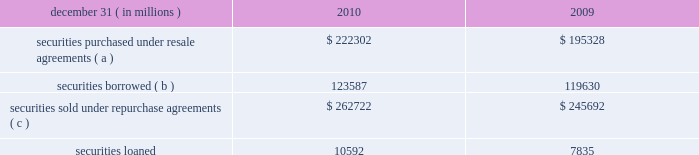Jpmorgan chase & co./2010 annual report 219 note 13 2013 securities financing activities jpmorgan chase enters into resale agreements , repurchase agreements , securities borrowed transactions and securities loaned transactions ( collectively , 201csecurities financing agree- ments 201d ) primarily to finance the firm 2019s inventory positions , ac- quire securities to cover short positions , accommodate customers 2019 financing needs , and settle other securities obligations .
Securities financing agreements are treated as collateralized financings on the firm 2019s consolidated balance sheets .
Resale and repurchase agreements are generally carried at the amounts at which the securities will be subsequently sold or repurchased , plus accrued interest .
Securities borrowed and securities loaned transactions are generally carried at the amount of cash collateral advanced or received .
Where appropriate under applicable ac- counting guidance , resale and repurchase agreements with the same counterparty are reported on a net basis .
Fees received or paid in connection with securities financing agreements are recorded in interest income or interest expense .
The firm has elected the fair value option for certain securities financing agreements .
For a further discussion of the fair value option , see note 4 on pages 187 2013189 of this annual report .
The securities financing agreements for which the fair value option has been elected are reported within securities purchased under resale agreements ; securities loaned or sold under repurchase agreements ; and securities borrowed on the consolidated bal- ance sheets .
Generally , for agreements carried at fair value , current-period interest accruals are recorded within interest income and interest expense , with changes in fair value reported in principal transactions revenue .
However , for financial instru- ments containing embedded derivatives that would be separately accounted for in accordance with accounting guidance for hybrid instruments , all changes in fair value , including any interest elements , are reported in principal transactions revenue .
The table details the firm 2019s securities financing agree- ments , all of which are accounted for as collateralized financings during the periods presented. .
( a ) includes resale agreements of $ 20.3 billion and $ 20.5 billion accounted for at fair value at december 31 , 2010 and 2009 , respectively .
( b ) includes securities borrowed of $ 14.0 billion and $ 7.0 billion accounted for at fair value at december 31 , 2010 and 2009 , respectively .
( c ) includes repurchase agreements of $ 4.1 billion and $ 3.4 billion accounted for at fair value at december 31 , 2010 and 2009 , respectively .
The amounts reported in the table above have been reduced by $ 112.7 billion and $ 121.2 billion at december 31 , 2010 and 2009 , respectively , as a result of agreements in effect that meet the specified conditions for net presentation under applicable accounting guidance .
Jpmorgan chase 2019s policy is to take possession , where possible , of securities purchased under resale agreements and of securi- ties borrowed .
The firm monitors the market value of the un- derlying securities that it has received from its counterparties and either requests additional collateral or returns a portion of the collateral when appropriate in light of the market value of the underlying securities .
Margin levels are established initially based upon the counterparty and type of collateral and moni- tored on an ongoing basis to protect against declines in collat- eral value in the event of default .
Jpmorgan chase typically enters into master netting agreements and other collateral arrangements with its resale agreement and securities bor- rowed counterparties , which provide for the right to liquidate the purchased or borrowed securities in the event of a customer default .
As a result of the firm 2019s credit risk mitigation practices described above on resale and securities borrowed agreements , the firm did not hold any reserves for credit impairment on these agreements as of december 31 , 2010 and 2009 .
For a further discussion of assets pledged and collateral received in securities financing agreements see note 31 on pages 280 2013 281 of this annual report. .
In 2010 what was the ratio of the securities borrowed to the securities loaned? 
Computations: (123587 / 10592)
Answer: 11.66796. Jpmorgan chase & co./2010 annual report 219 note 13 2013 securities financing activities jpmorgan chase enters into resale agreements , repurchase agreements , securities borrowed transactions and securities loaned transactions ( collectively , 201csecurities financing agree- ments 201d ) primarily to finance the firm 2019s inventory positions , ac- quire securities to cover short positions , accommodate customers 2019 financing needs , and settle other securities obligations .
Securities financing agreements are treated as collateralized financings on the firm 2019s consolidated balance sheets .
Resale and repurchase agreements are generally carried at the amounts at which the securities will be subsequently sold or repurchased , plus accrued interest .
Securities borrowed and securities loaned transactions are generally carried at the amount of cash collateral advanced or received .
Where appropriate under applicable ac- counting guidance , resale and repurchase agreements with the same counterparty are reported on a net basis .
Fees received or paid in connection with securities financing agreements are recorded in interest income or interest expense .
The firm has elected the fair value option for certain securities financing agreements .
For a further discussion of the fair value option , see note 4 on pages 187 2013189 of this annual report .
The securities financing agreements for which the fair value option has been elected are reported within securities purchased under resale agreements ; securities loaned or sold under repurchase agreements ; and securities borrowed on the consolidated bal- ance sheets .
Generally , for agreements carried at fair value , current-period interest accruals are recorded within interest income and interest expense , with changes in fair value reported in principal transactions revenue .
However , for financial instru- ments containing embedded derivatives that would be separately accounted for in accordance with accounting guidance for hybrid instruments , all changes in fair value , including any interest elements , are reported in principal transactions revenue .
The table details the firm 2019s securities financing agree- ments , all of which are accounted for as collateralized financings during the periods presented. .
( a ) includes resale agreements of $ 20.3 billion and $ 20.5 billion accounted for at fair value at december 31 , 2010 and 2009 , respectively .
( b ) includes securities borrowed of $ 14.0 billion and $ 7.0 billion accounted for at fair value at december 31 , 2010 and 2009 , respectively .
( c ) includes repurchase agreements of $ 4.1 billion and $ 3.4 billion accounted for at fair value at december 31 , 2010 and 2009 , respectively .
The amounts reported in the table above have been reduced by $ 112.7 billion and $ 121.2 billion at december 31 , 2010 and 2009 , respectively , as a result of agreements in effect that meet the specified conditions for net presentation under applicable accounting guidance .
Jpmorgan chase 2019s policy is to take possession , where possible , of securities purchased under resale agreements and of securi- ties borrowed .
The firm monitors the market value of the un- derlying securities that it has received from its counterparties and either requests additional collateral or returns a portion of the collateral when appropriate in light of the market value of the underlying securities .
Margin levels are established initially based upon the counterparty and type of collateral and moni- tored on an ongoing basis to protect against declines in collat- eral value in the event of default .
Jpmorgan chase typically enters into master netting agreements and other collateral arrangements with its resale agreement and securities bor- rowed counterparties , which provide for the right to liquidate the purchased or borrowed securities in the event of a customer default .
As a result of the firm 2019s credit risk mitigation practices described above on resale and securities borrowed agreements , the firm did not hold any reserves for credit impairment on these agreements as of december 31 , 2010 and 2009 .
For a further discussion of assets pledged and collateral received in securities financing agreements see note 31 on pages 280 2013 281 of this annual report. .
What would the 2010 balance be in billions for securities purchased under resale agreements if the fair value resale agreements were excluded? 
Computations: (222302 / 1000)
Answer: 222.302. 